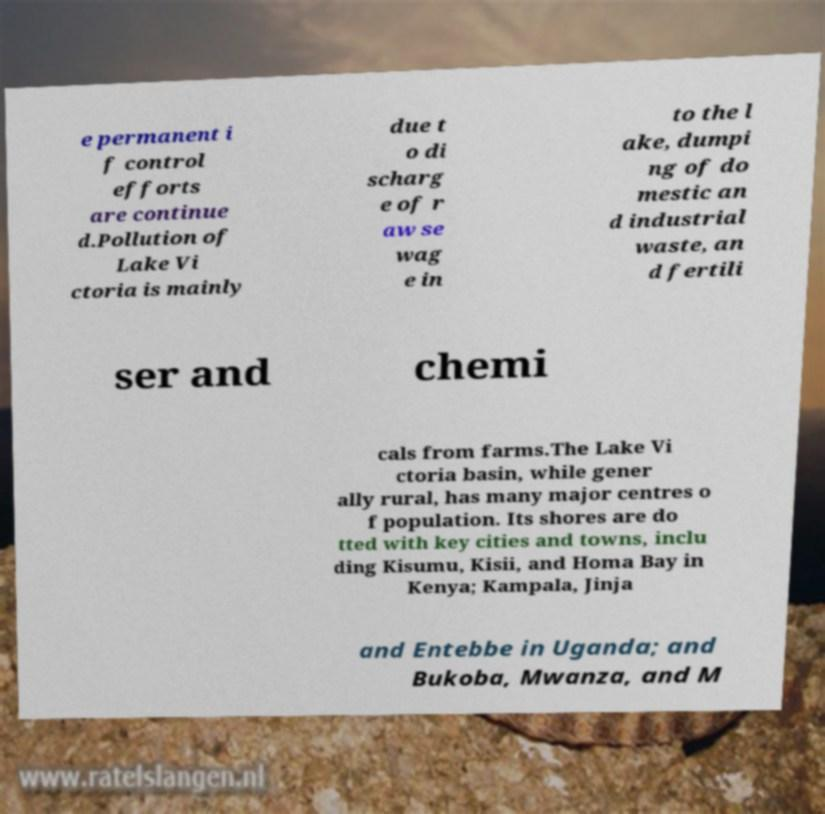Could you assist in decoding the text presented in this image and type it out clearly? e permanent i f control efforts are continue d.Pollution of Lake Vi ctoria is mainly due t o di scharg e of r aw se wag e in to the l ake, dumpi ng of do mestic an d industrial waste, an d fertili ser and chemi cals from farms.The Lake Vi ctoria basin, while gener ally rural, has many major centres o f population. Its shores are do tted with key cities and towns, inclu ding Kisumu, Kisii, and Homa Bay in Kenya; Kampala, Jinja and Entebbe in Uganda; and Bukoba, Mwanza, and M 